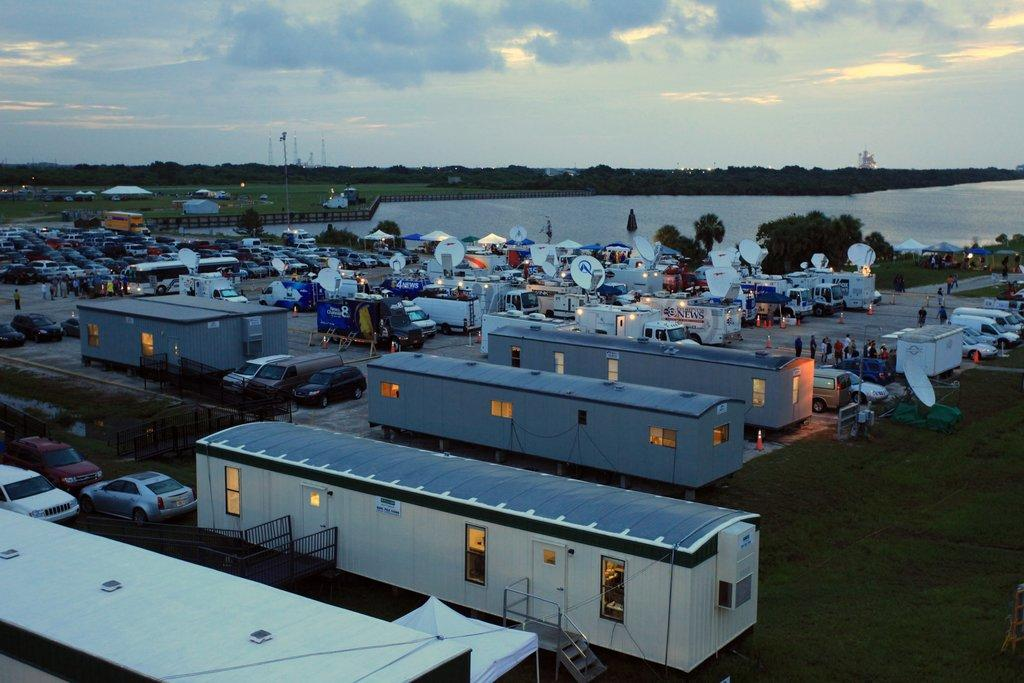What structures are located at the bottom of the image? There are sheds and vehicles at the bottom of the image. What can be found near the sheds and vehicles? There are lights at the bottom of the image. What type of barriers are present in the image? There are fences in the image. What can be seen in the background of the image? There is a canal, trees, poles, tents, and the sky visible in the background of the image. What are the hobbies of the zinc in the image? There is no zinc present in the image, and therefore no hobbies can be attributed to it. What does the self think about the tents in the background? There is no self present in the image, so their thoughts about the tents cannot be determined. 